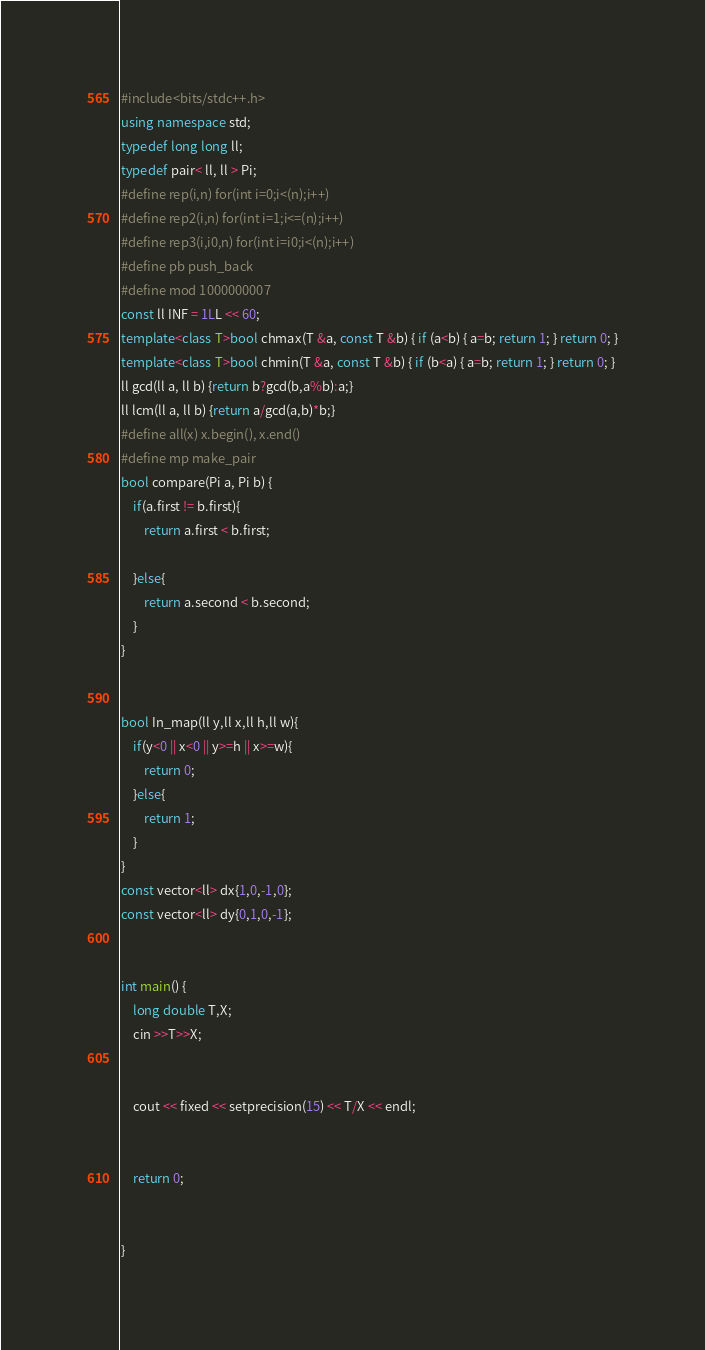<code> <loc_0><loc_0><loc_500><loc_500><_C++_>#include<bits/stdc++.h>
using namespace std;
typedef long long ll;
typedef pair< ll, ll > Pi;
#define rep(i,n) for(int i=0;i<(n);i++)
#define rep2(i,n) for(int i=1;i<=(n);i++)
#define rep3(i,i0,n) for(int i=i0;i<(n);i++)
#define pb push_back
#define mod 1000000007
const ll INF = 1LL << 60;
template<class T>bool chmax(T &a, const T &b) { if (a<b) { a=b; return 1; } return 0; }
template<class T>bool chmin(T &a, const T &b) { if (b<a) { a=b; return 1; } return 0; }
ll gcd(ll a, ll b) {return b?gcd(b,a%b):a;}
ll lcm(ll a, ll b) {return a/gcd(a,b)*b;}
#define all(x) x.begin(), x.end()
#define mp make_pair
bool compare(Pi a, Pi b) {
    if(a.first != b.first){
        return a.first < b.first;
        
    }else{
        return a.second < b.second;
    }
}


bool In_map(ll y,ll x,ll h,ll w){
    if(y<0 || x<0 || y>=h || x>=w){
        return 0;
    }else{
        return 1;
    }
}
const vector<ll> dx{1,0,-1,0};
const vector<ll> dy{0,1,0,-1};


int main() {
    long double T,X;
    cin >>T>>X;
    

    cout << fixed << setprecision(15) << T/X << endl;


    return 0;
    

}</code> 